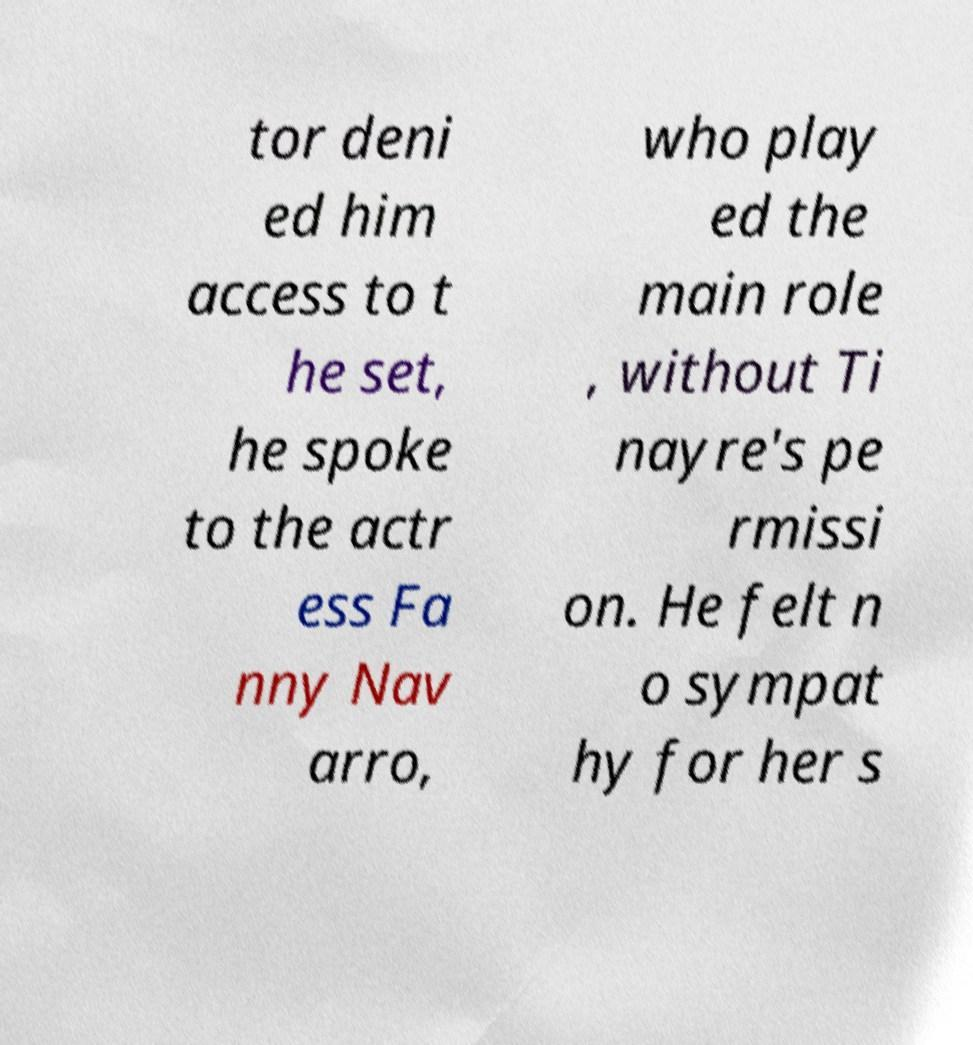Could you extract and type out the text from this image? tor deni ed him access to t he set, he spoke to the actr ess Fa nny Nav arro, who play ed the main role , without Ti nayre's pe rmissi on. He felt n o sympat hy for her s 